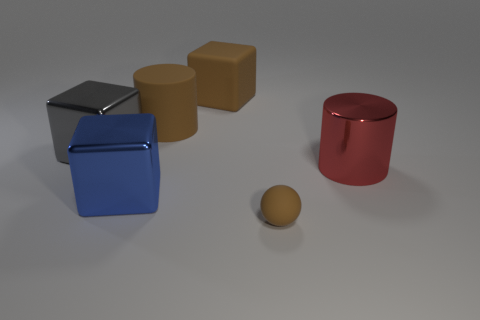There is a block that is the same color as the tiny ball; what is its material?
Your answer should be compact. Rubber. There is a big object that is the same color as the matte cylinder; what shape is it?
Ensure brevity in your answer.  Cube. What number of large blue metal blocks are left of the big metal thing that is right of the large brown matte cylinder?
Your answer should be very brief. 1. Are there fewer brown matte cylinders that are on the right side of the small brown matte object than large metallic cylinders in front of the blue metal cube?
Ensure brevity in your answer.  No. There is a brown thing in front of the big block on the left side of the blue block; what is its shape?
Ensure brevity in your answer.  Sphere. How many other things are there of the same material as the tiny brown object?
Your answer should be compact. 2. Is there any other thing that is the same size as the brown rubber block?
Provide a short and direct response. Yes. Are there more big green matte cylinders than blue cubes?
Your answer should be compact. No. How big is the blue cube that is on the left side of the large cylinder behind the big metal object right of the big brown cylinder?
Your response must be concise. Large. Is the size of the gray metallic block the same as the block in front of the big red object?
Offer a very short reply. Yes. 